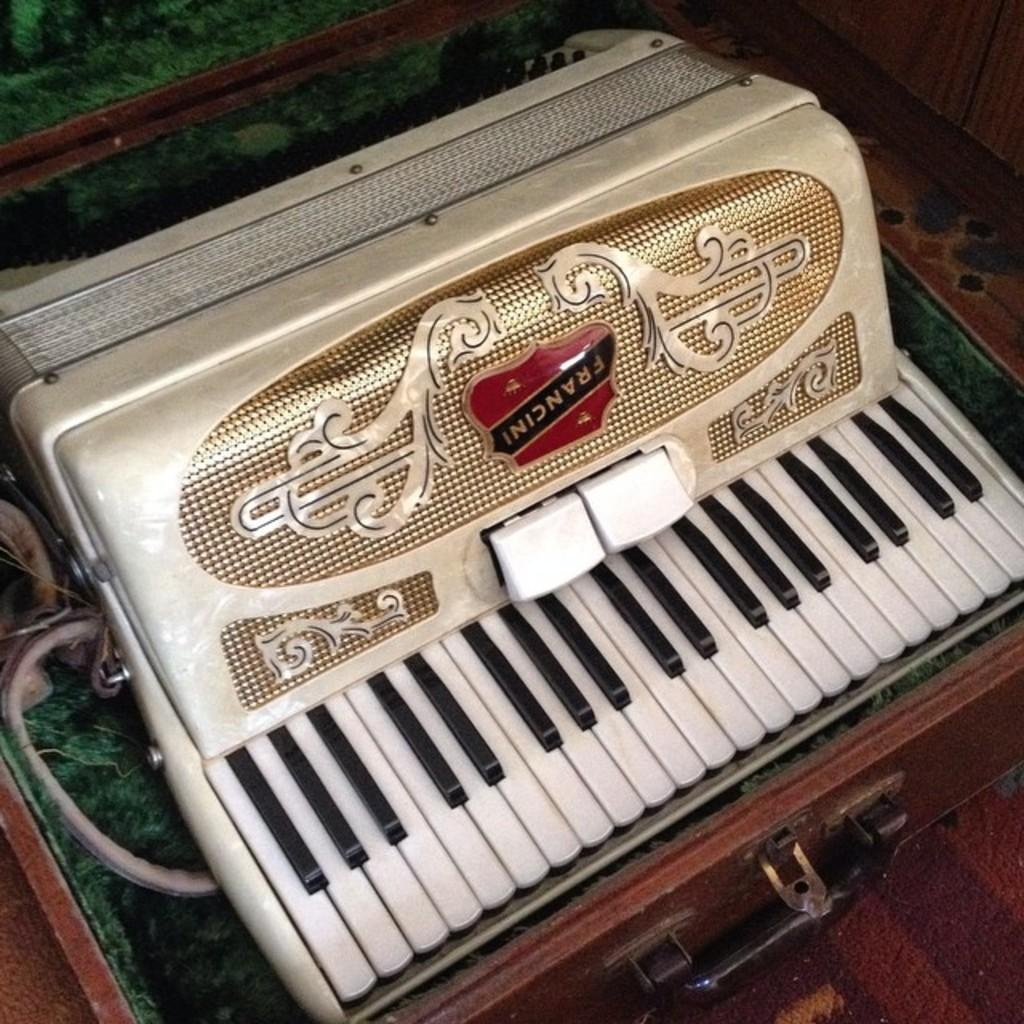What musical instrument is present in the image? There is a piano in the image. What are the keys on the piano like? The piano has black and white keys. Where is the piano located in the image? The piano is on a table. What type of magic does the piano perform in the image? There is no magic performed by the piano in the image; it is a regular piano with black and white keys. 